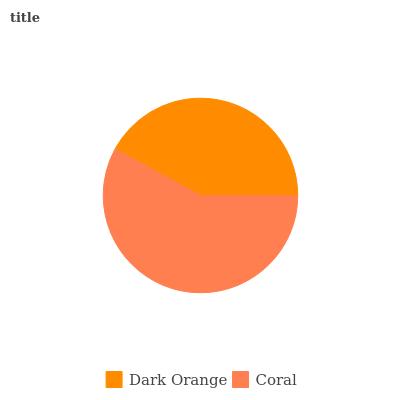Is Dark Orange the minimum?
Answer yes or no. Yes. Is Coral the maximum?
Answer yes or no. Yes. Is Coral the minimum?
Answer yes or no. No. Is Coral greater than Dark Orange?
Answer yes or no. Yes. Is Dark Orange less than Coral?
Answer yes or no. Yes. Is Dark Orange greater than Coral?
Answer yes or no. No. Is Coral less than Dark Orange?
Answer yes or no. No. Is Coral the high median?
Answer yes or no. Yes. Is Dark Orange the low median?
Answer yes or no. Yes. Is Dark Orange the high median?
Answer yes or no. No. Is Coral the low median?
Answer yes or no. No. 